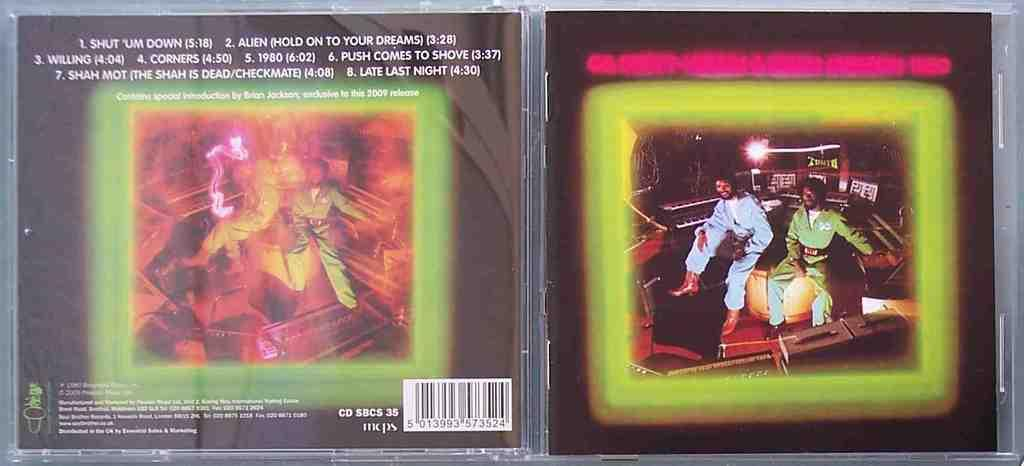<image>
Create a compact narrative representing the image presented. Compact disk album with special introduction by Brian Jackson. 